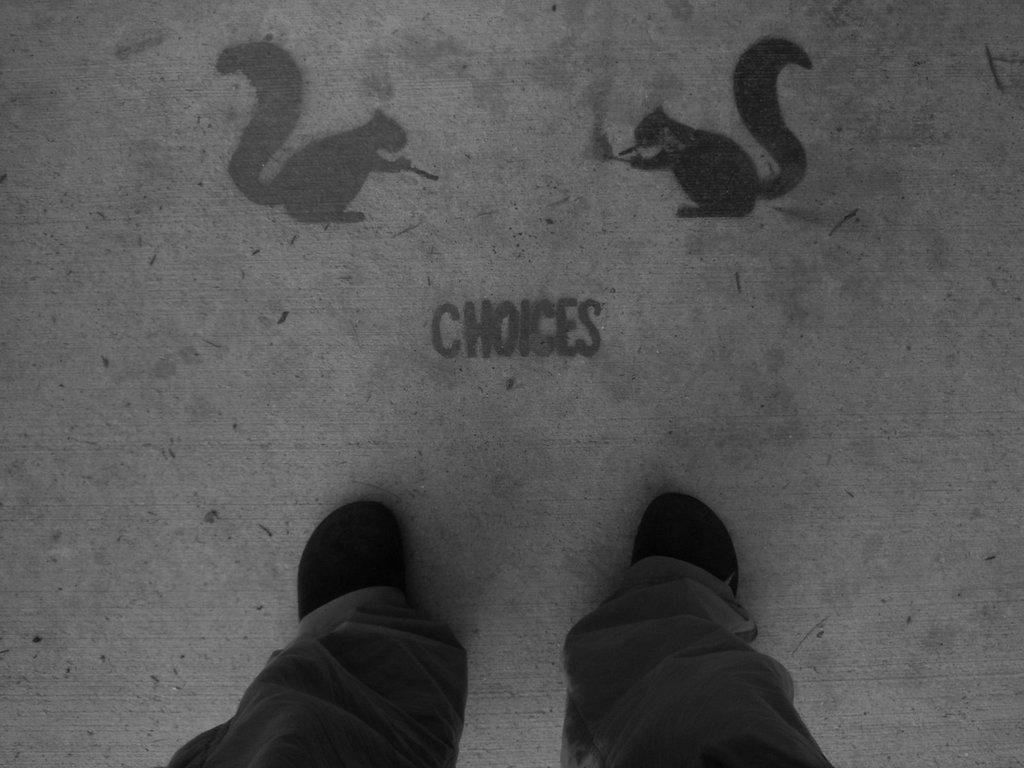What part of a person can be seen in the image? There are legs of a person visible in the image. What type of artwork is present in the image? There are two squirrel paintings in the image. What color is the ray in the image? There is no ray present in the image. What time of day is depicted in the image? The image does not depict a specific time of day. 